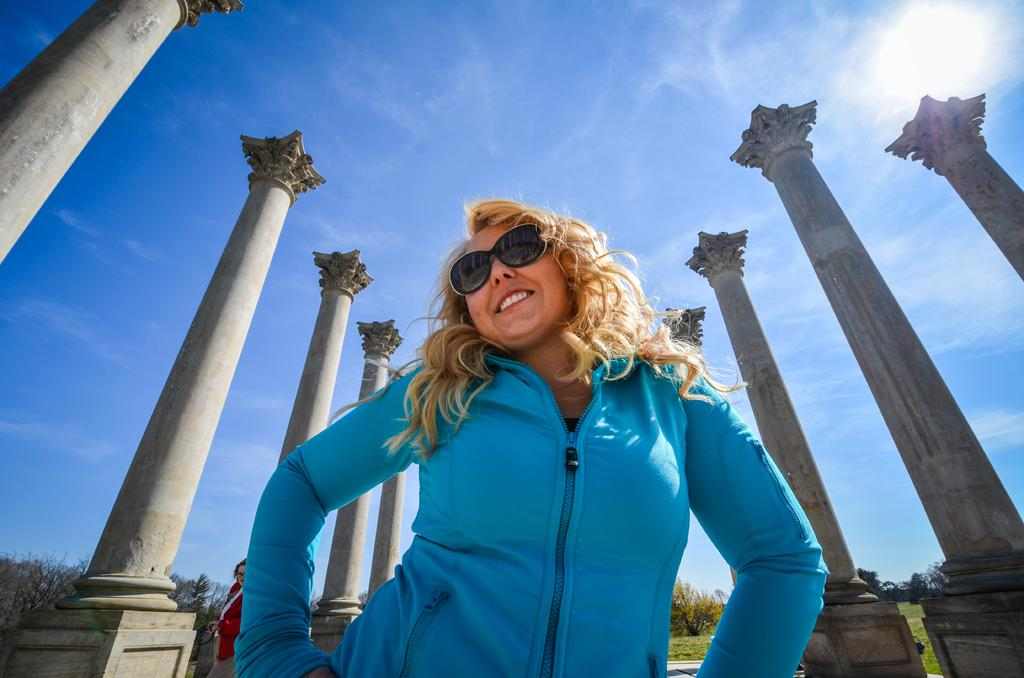Who is the main subject in the image? There is a woman in the center of the image. What architectural features can be seen in the image? There are pillars visible in the image. Can you describe the person standing in the image? There is a person standing in the image. What type of vegetation is present in the image? There is a group of trees in the image. What celestial body is visible in the image? The sun is visible in the image. How would you describe the weather based on the image? The sky appears cloudy in the image. What type of sign can be seen in the image? There is no sign present in the image. What mode of transportation is visible in the image? There are no trains or any other mode of transportation visible in the image. What type of food is being served in the image? There is no breakfast or any other food visible in the image. 